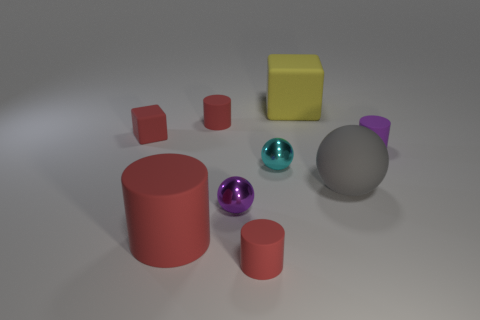Subtract all green cubes. How many red cylinders are left? 3 Add 1 cyan metallic spheres. How many objects exist? 10 Subtract all blocks. How many objects are left? 7 Add 6 purple metal things. How many purple metal things are left? 7 Add 8 tiny cyan shiny balls. How many tiny cyan shiny balls exist? 9 Subtract 1 purple balls. How many objects are left? 8 Subtract all big yellow rubber cubes. Subtract all tiny spheres. How many objects are left? 6 